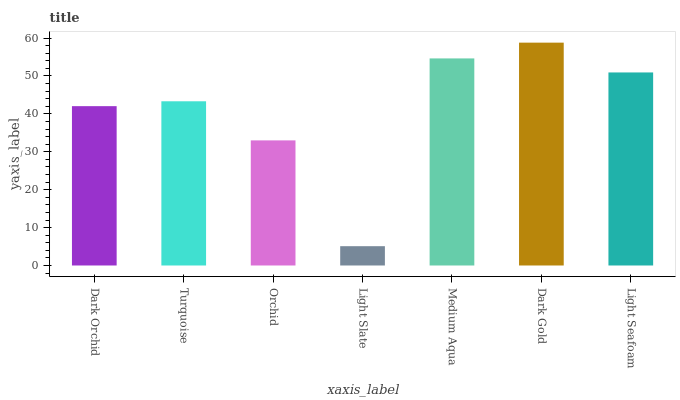Is Light Slate the minimum?
Answer yes or no. Yes. Is Dark Gold the maximum?
Answer yes or no. Yes. Is Turquoise the minimum?
Answer yes or no. No. Is Turquoise the maximum?
Answer yes or no. No. Is Turquoise greater than Dark Orchid?
Answer yes or no. Yes. Is Dark Orchid less than Turquoise?
Answer yes or no. Yes. Is Dark Orchid greater than Turquoise?
Answer yes or no. No. Is Turquoise less than Dark Orchid?
Answer yes or no. No. Is Turquoise the high median?
Answer yes or no. Yes. Is Turquoise the low median?
Answer yes or no. Yes. Is Orchid the high median?
Answer yes or no. No. Is Light Seafoam the low median?
Answer yes or no. No. 